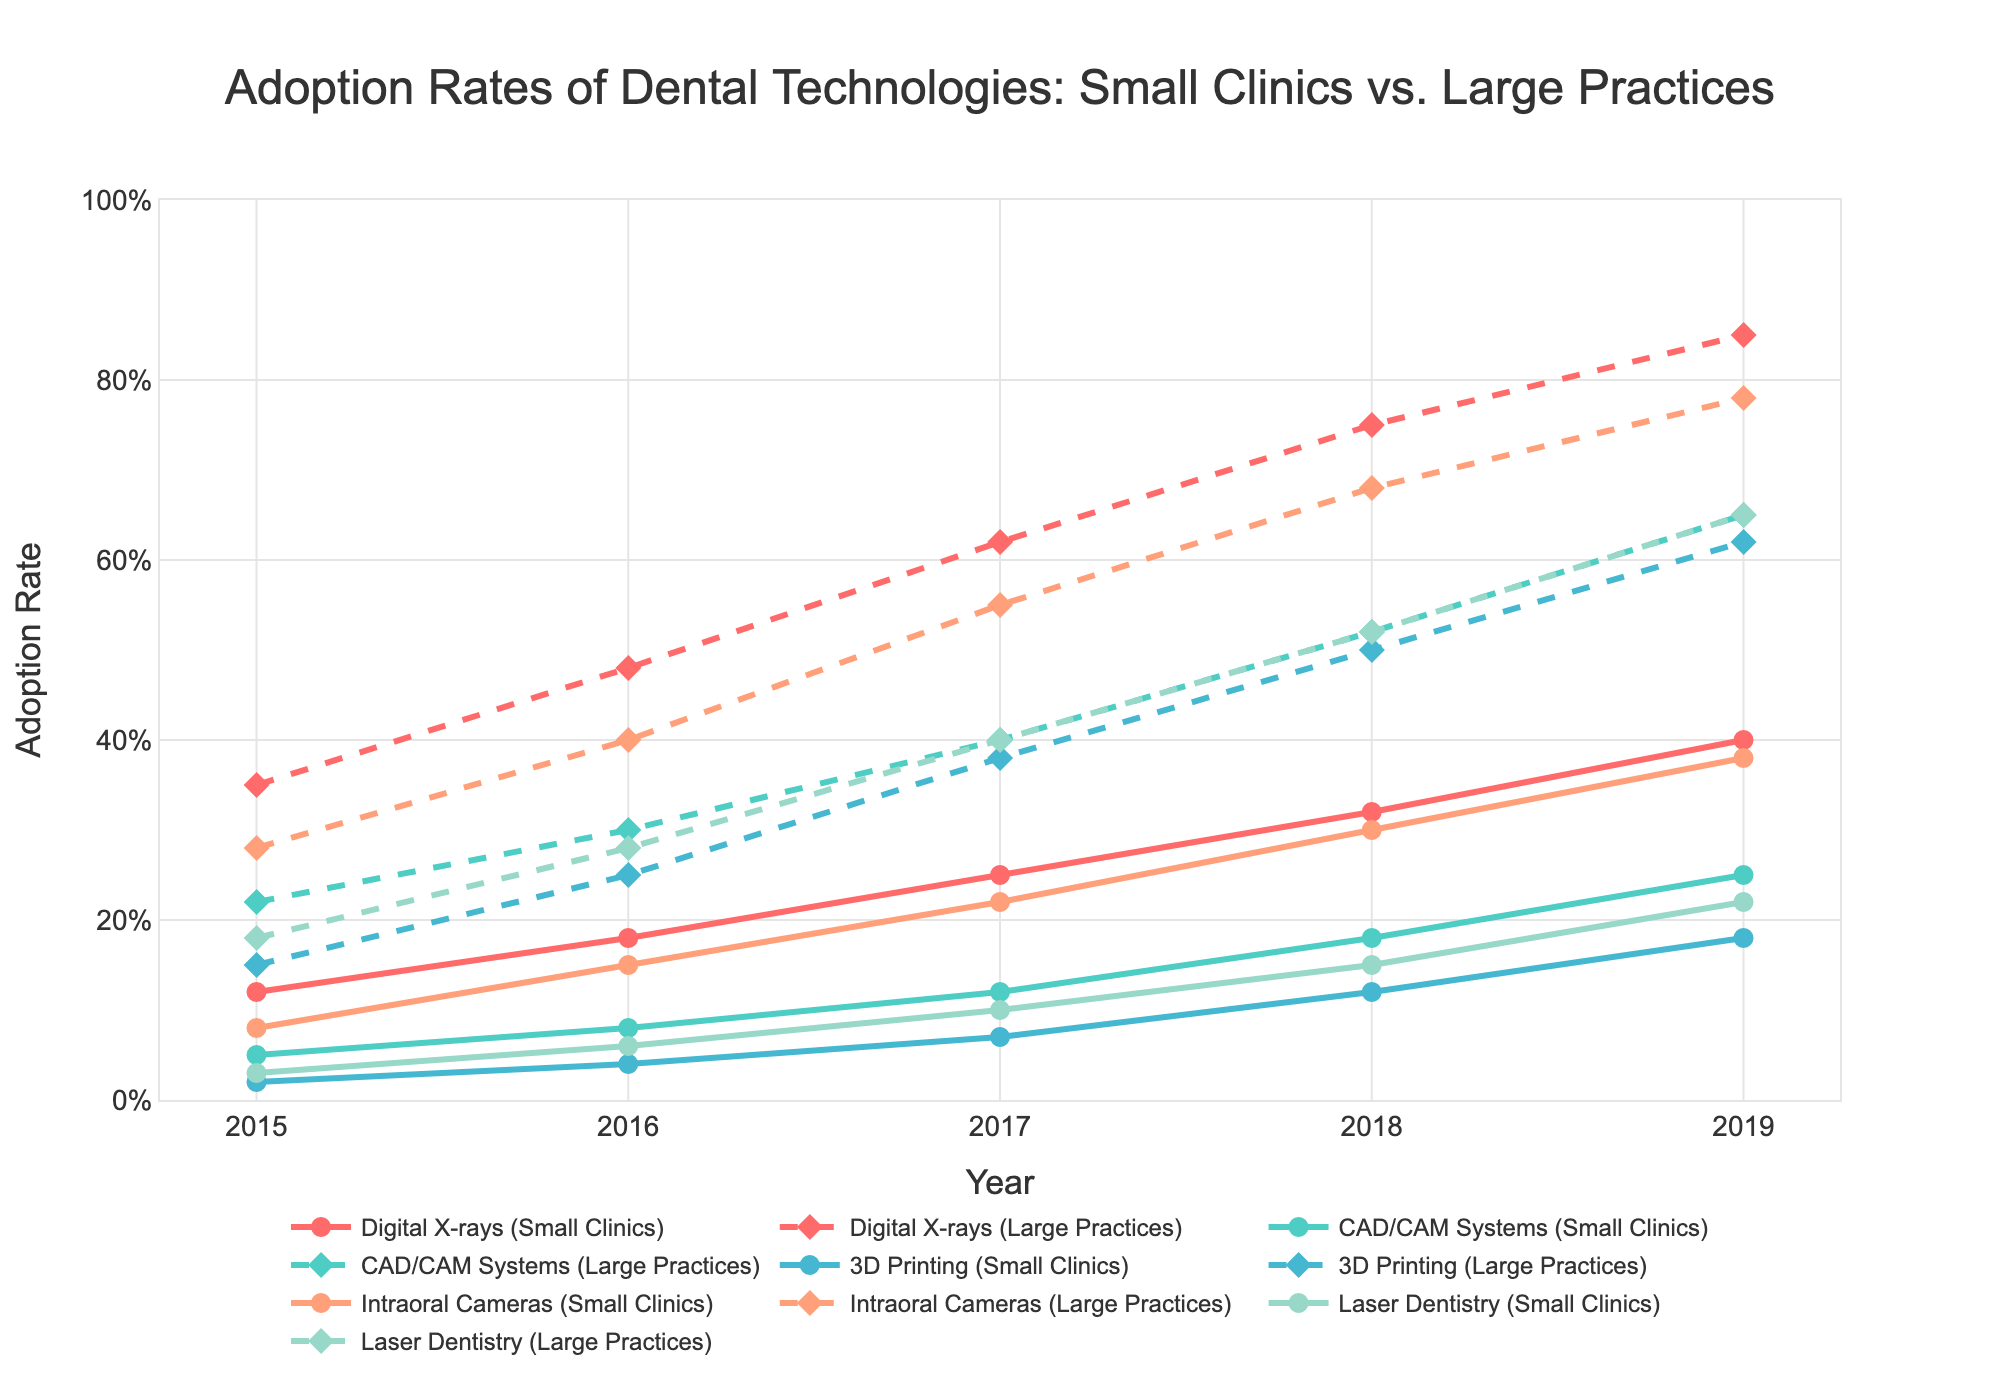Which technology shows the greatest increase in adoption rates for small clinics from 2015 to 2019? To find the technology with the greatest increase, subtract the 2015 adoption rate from the 2019 adoption rate for each technology in small clinics. Digital X-rays increased from 12% to 40% (28%), CAD/CAM Systems from 5% to 25% (20%), 3D Printing from 2% to 18% (16%), Intraoral Cameras from 8% to 38% (30%), and Laser Dentistry from 3% to 22% (19%).
Answer: Intraoral Cameras Which practice type had a higher adoption rate of CAD/CAM Systems in 2017, small clinics or large practices? Compare the adoption rates of CAD/CAM Systems in 2017 for both small clinics and large practices. Small clinics had 12%, while large practices had 40%.
Answer: Large practices What is the average adoption rate for Intraoral Cameras in small clinics from 2015 to 2019? To find the average, sum the adoption rates from 2015 to 2019 and divide by the number of years: (8% + 15% + 22% + 30% + 38%) / 5 = 113% / 5.
Answer: 22.6% Among the listed technologies, which one had the smallest difference in adoption rates between small clinics and large practices in 2019? Calculate the difference in adoption rates in 2019 for each technology between small clinics and large practices: Digital X-rays (40%-85%=45%), CAD/CAM Systems (25%-65%=40%), 3D Printing (18%-62%=44%), Intraoral Cameras (38%-78%=40%), Laser Dentistry (22%-65%=43%).
Answer: CAD/CAM Systems In which year did small clinics see the highest percentage point increase in adoption rates for 3D Printing compared to the previous year? Check the year-over-year changes for 3D Printing: 2016-2015 (4%-2%=2%), 2017-2016 (7%-4%=3%), 2018-2017 (12%-7%=5%), 2019-2018 (18%-12%=6%). The greatest increase is 2019-2018.
Answer: 2019 Which technology had the fastest adoption increase in large practices from 2015 to 2016? Calculate the increase for each technology in large practices from 2015 to 2016: Digital X-rays (48%-35%=13%), CAD/CAM Systems (30%-22%=8%), 3D Printing (25%-15%=10%), Intraoral Cameras (40%-28%=12%), Laser Dentistry (28%-18%=10%).
Answer: Digital X-rays How did the adoption rate of Digital X-rays in large practices change from 2015 to 2019? To find the change, look at 2015 and 2019 rates for Digital X-rays in large practices: 85%-35%.
Answer: Increased by 50% What trend can be observed for the adoption rates of Laser Dentistry in both small clinics and large practices over the years? Analyze the trend for Laser Dentistry: both small clinics and large practices show a steady increase each year from 2015 to 2019.
Answer: Steady increase 